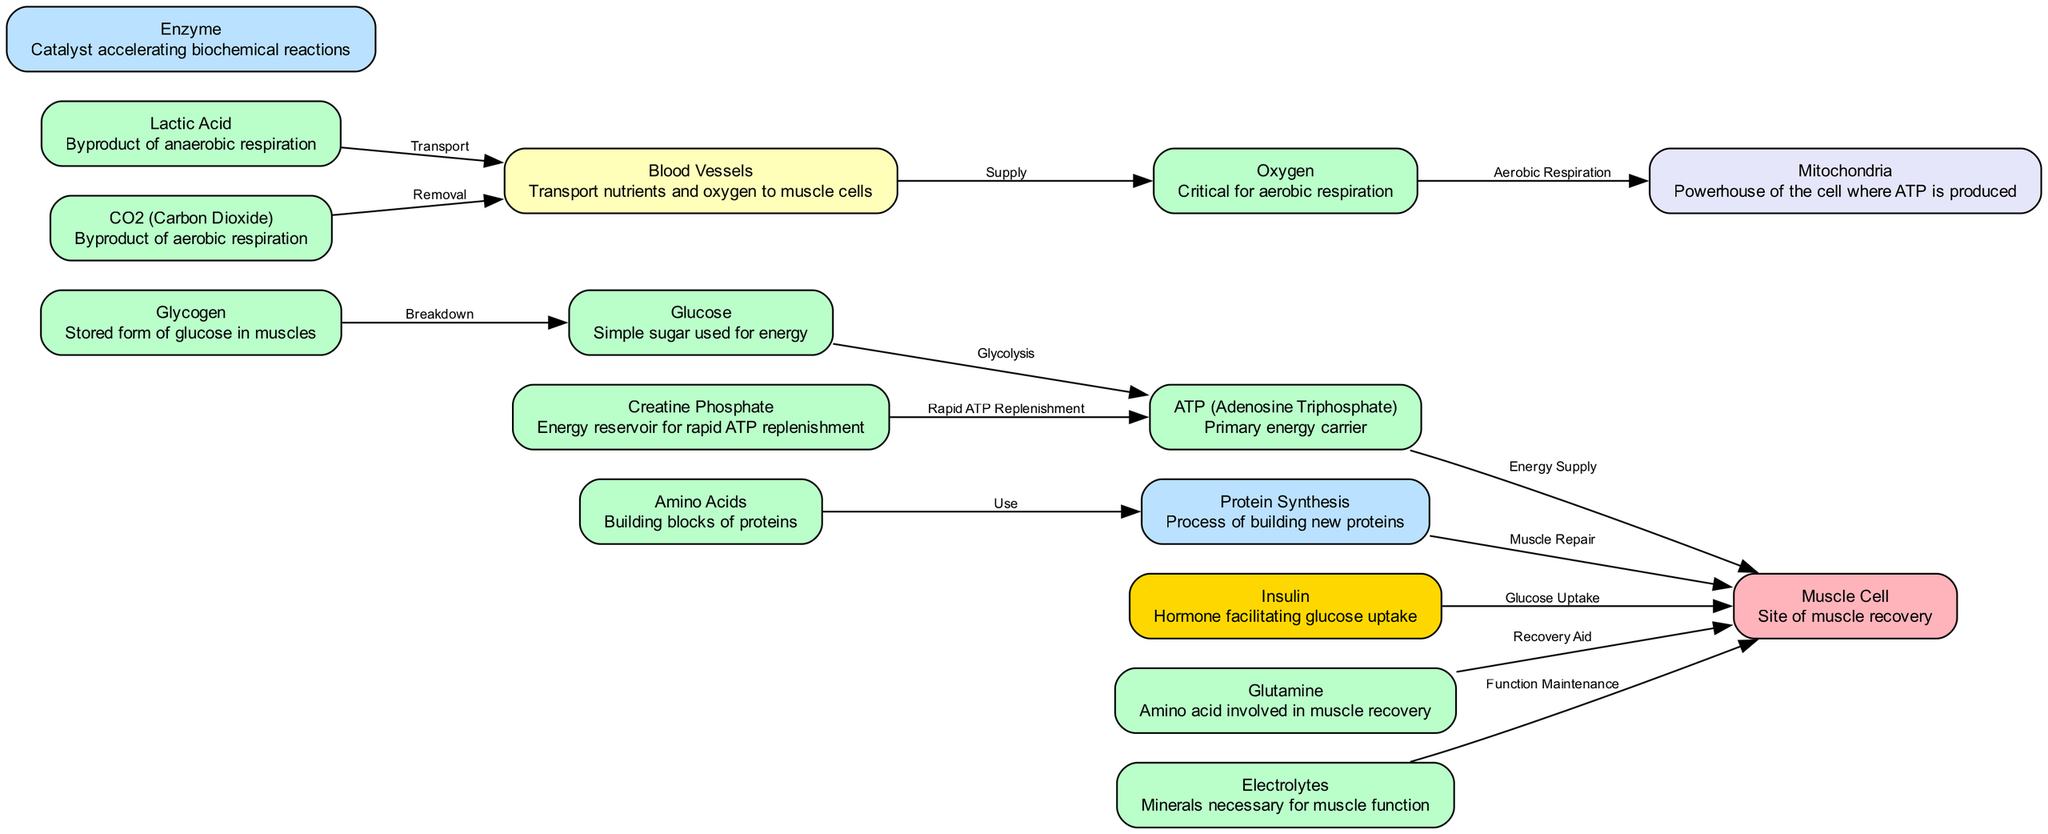What is the primary energy carrier in muscle recovery? The diagram indicates that ATP (Adenosine Triphosphate) is the primary energy carrier as described in the node labeled "ATP." It directly influences energy supply to muscle cells.
Answer: ATP (Adenosine Triphosphate) How many nutrients are directly supplied to muscle cells? From the diagram, we can see that glucose, amino acids, and electrolytes are all nutrients that are supplied to muscle cells, bringing the total to three specific nutrients.
Answer: Three Which process involves the breakdown of glycogen? The diagram shows that glycogen is broken down into glucose, as indicated by the labeled edge between the "glycogen" and "glucose" nodes, which denotes the process "Breakdown."
Answer: Breakdown What molecule aids in the rapid replenishment of ATP? The diagram identifies creatine phosphate as an energy reservoir for rapid ATP replenishment, indicated by the edge connecting "creatine phosphate" to "ATP."
Answer: Creatine Phosphate Which hormone facilitates glucose uptake into muscle cells? According to the diagram, insulin is the hormone that facilitates glucose uptake into muscle cells, as detailed by the edge from the "insulin" node pointing to the "muscle cell" node labeled "Glucose Uptake."
Answer: Insulin How does oxygen contribute to ATP production? The diagram outlines that oxygen is supplied to mitochondria, where aerobic respiration occurs to produce ATP, represented by the edges connecting "oxygen" to "mitochondria."
Answer: Aerobic Respiration What is produced as a byproduct of anaerobic respiration in muscle cells? The diagram lists lactic acid as a byproduct of anaerobic respiration, which is shown in the "lactic acid" node.
Answer: Lactic Acid Which nutrients are indicated to assist in muscle repair? The diagram conveys that amino acids and glutamine are both directly involved in muscle repair, as indicated by the relationships leading to muscle cell recovery from their respective nodes.
Answer: Amino Acids, Glutamine How is carbon dioxide removed from muscle tissue? The diagram describes that CO2 is transported away from muscle tissue via blood vessels for removal, detailed by the edge connecting the "CO2" and "blood vessels" nodes.
Answer: Transport 